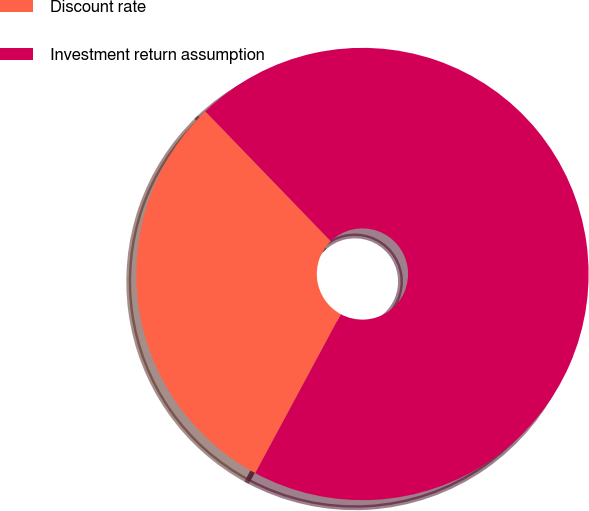<chart> <loc_0><loc_0><loc_500><loc_500><pie_chart><fcel>Discount rate<fcel>Investment return assumption<nl><fcel>29.92%<fcel>70.08%<nl></chart> 